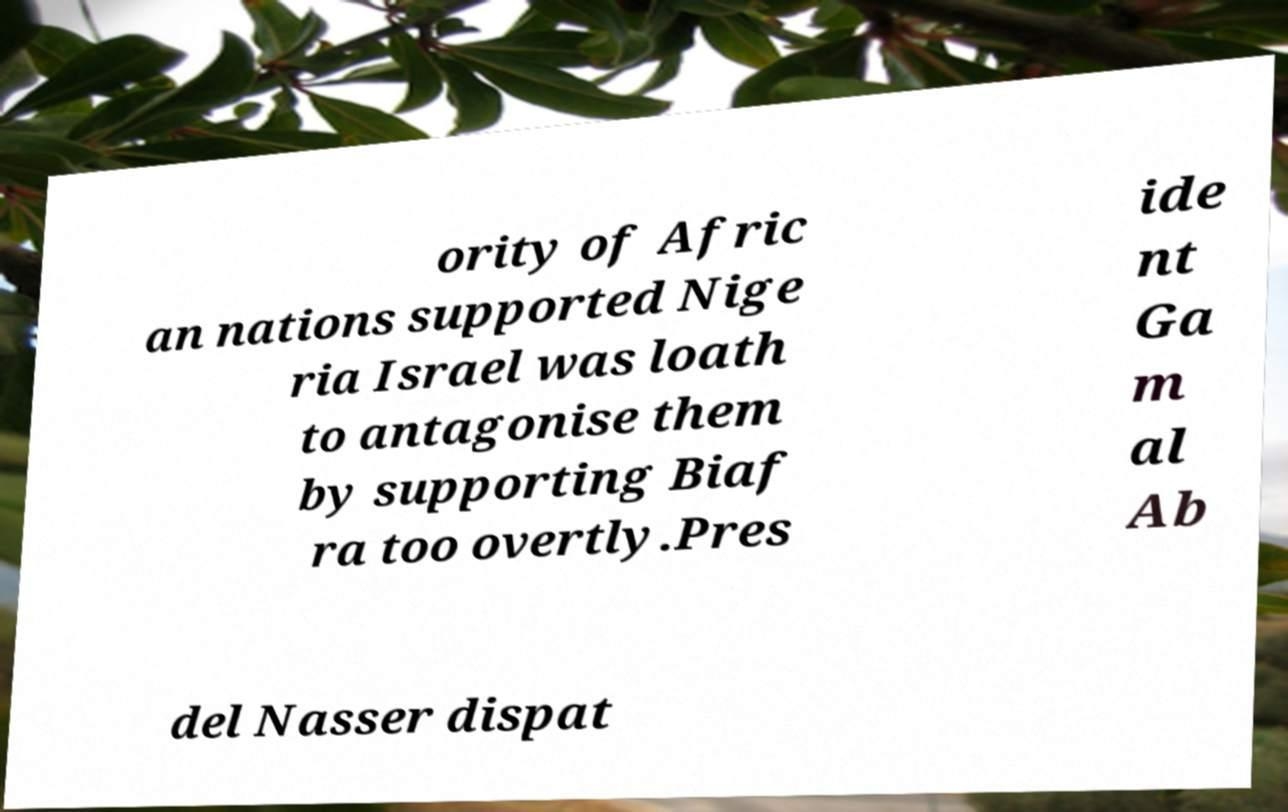Can you accurately transcribe the text from the provided image for me? ority of Afric an nations supported Nige ria Israel was loath to antagonise them by supporting Biaf ra too overtly.Pres ide nt Ga m al Ab del Nasser dispat 